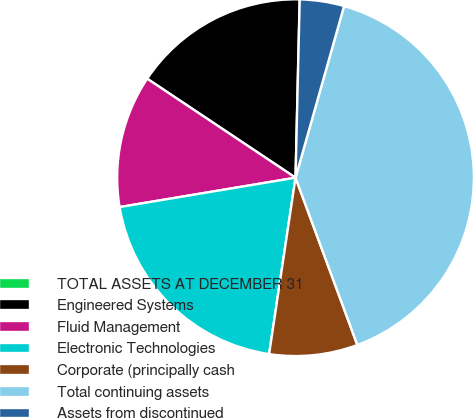Convert chart to OTSL. <chart><loc_0><loc_0><loc_500><loc_500><pie_chart><fcel>TOTAL ASSETS AT DECEMBER 31<fcel>Engineered Systems<fcel>Fluid Management<fcel>Electronic Technologies<fcel>Corporate (principally cash<fcel>Total continuing assets<fcel>Assets from discontinued<nl><fcel>0.01%<fcel>16.0%<fcel>12.0%<fcel>20.0%<fcel>8.0%<fcel>39.98%<fcel>4.01%<nl></chart> 